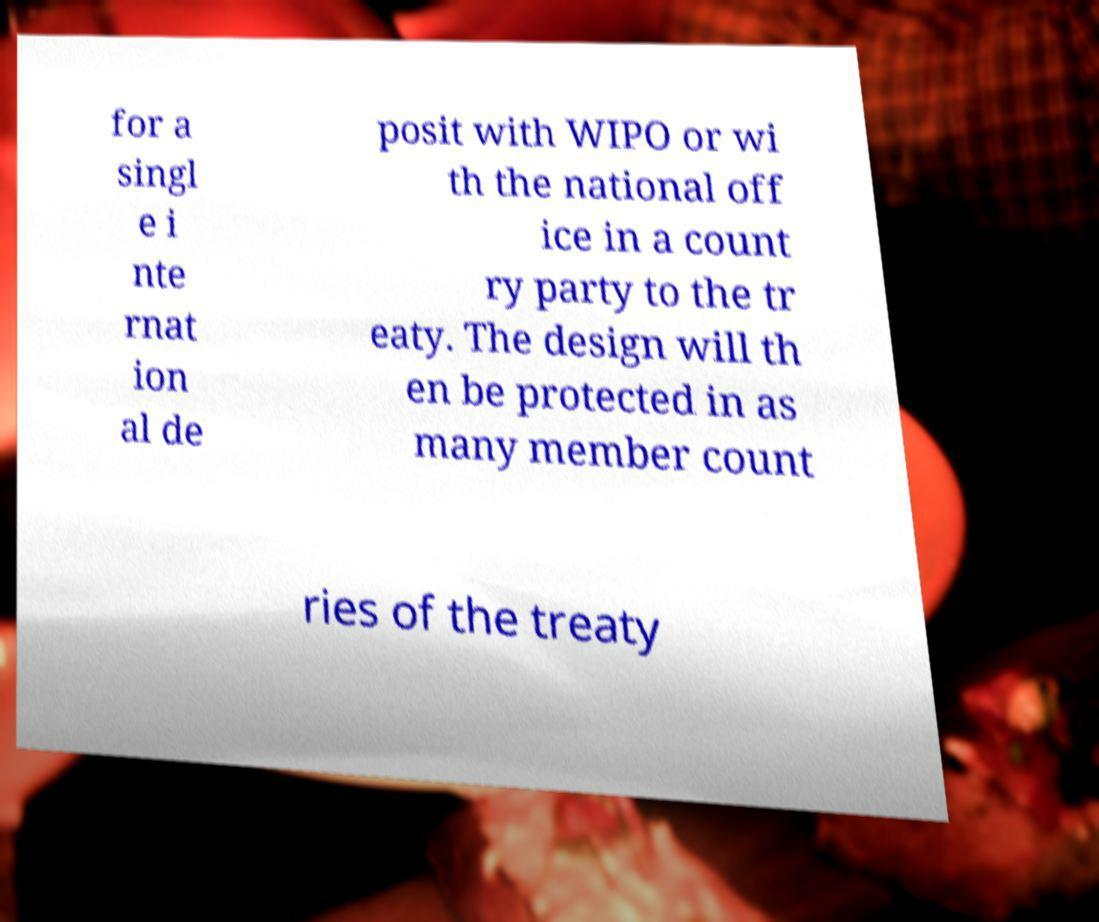There's text embedded in this image that I need extracted. Can you transcribe it verbatim? for a singl e i nte rnat ion al de posit with WIPO or wi th the national off ice in a count ry party to the tr eaty. The design will th en be protected in as many member count ries of the treaty 